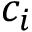Convert formula to latex. <formula><loc_0><loc_0><loc_500><loc_500>c _ { i }</formula> 